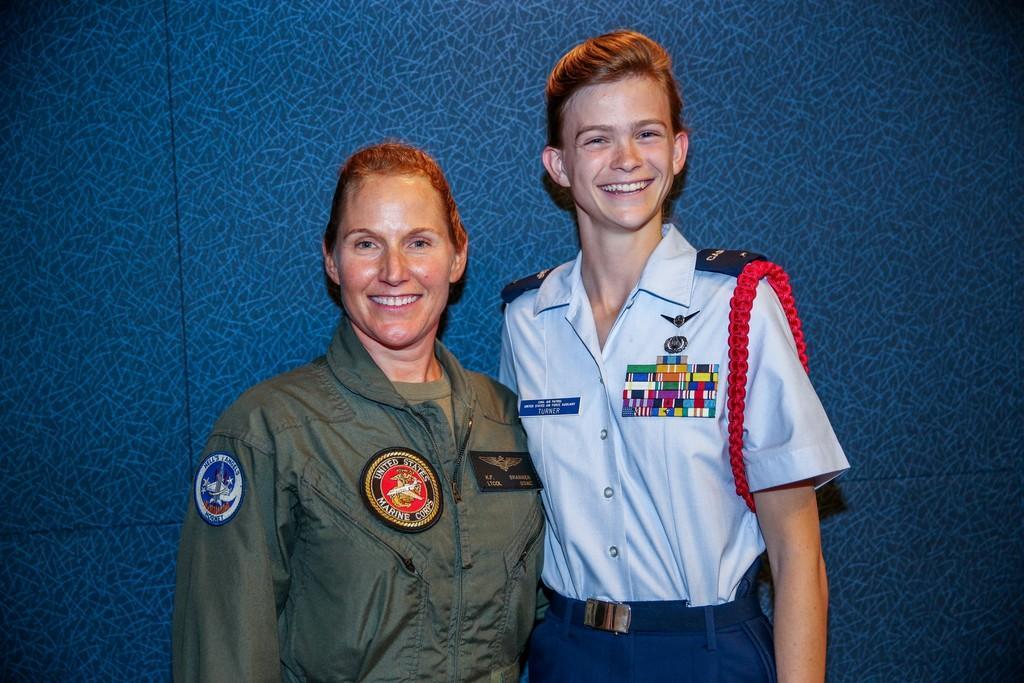Can you describe this image briefly? In this picture we can see couple of people and they both are smiling. 